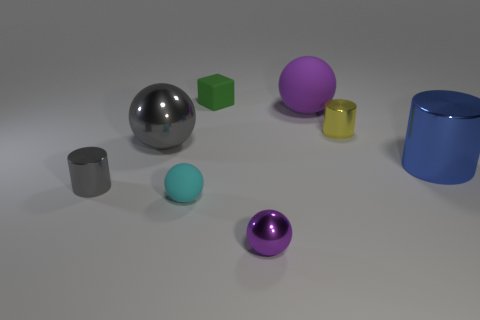What is the material of the green object that is to the right of the cyan object?
Offer a terse response. Rubber. How many blue things have the same shape as the big gray metallic thing?
Your response must be concise. 0. There is a object that is in front of the tiny rubber object that is to the left of the small green thing; what is it made of?
Ensure brevity in your answer.  Metal. The tiny metal object that is the same color as the big rubber object is what shape?
Make the answer very short. Sphere. Are there any other cubes made of the same material as the small cube?
Your answer should be very brief. No. There is a large blue thing; what shape is it?
Provide a succinct answer. Cylinder. How many yellow metal cylinders are there?
Keep it short and to the point. 1. What color is the big metal thing on the left side of the small sphere in front of the small cyan sphere?
Provide a short and direct response. Gray. What color is the block that is the same size as the gray metal cylinder?
Offer a very short reply. Green. Are there any small matte spheres that have the same color as the tiny shiny sphere?
Your response must be concise. No. 